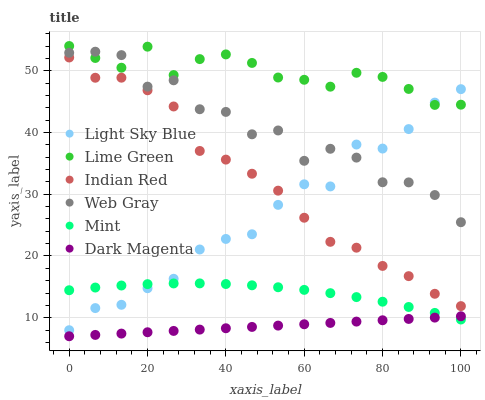Does Dark Magenta have the minimum area under the curve?
Answer yes or no. Yes. Does Lime Green have the maximum area under the curve?
Answer yes or no. Yes. Does Lime Green have the minimum area under the curve?
Answer yes or no. No. Does Dark Magenta have the maximum area under the curve?
Answer yes or no. No. Is Dark Magenta the smoothest?
Answer yes or no. Yes. Is Web Gray the roughest?
Answer yes or no. Yes. Is Lime Green the smoothest?
Answer yes or no. No. Is Lime Green the roughest?
Answer yes or no. No. Does Dark Magenta have the lowest value?
Answer yes or no. Yes. Does Lime Green have the lowest value?
Answer yes or no. No. Does Lime Green have the highest value?
Answer yes or no. Yes. Does Dark Magenta have the highest value?
Answer yes or no. No. Is Dark Magenta less than Indian Red?
Answer yes or no. Yes. Is Web Gray greater than Indian Red?
Answer yes or no. Yes. Does Web Gray intersect Lime Green?
Answer yes or no. Yes. Is Web Gray less than Lime Green?
Answer yes or no. No. Is Web Gray greater than Lime Green?
Answer yes or no. No. Does Dark Magenta intersect Indian Red?
Answer yes or no. No. 